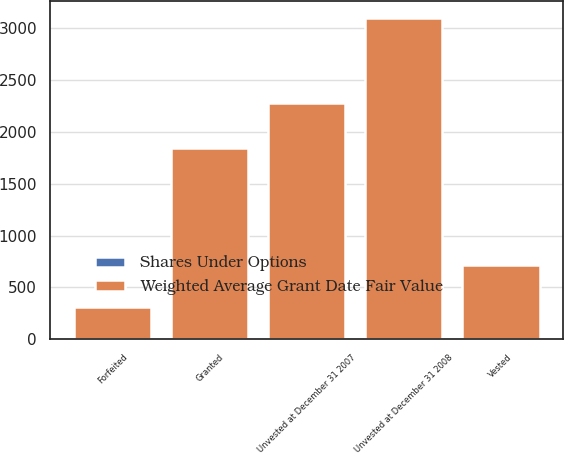<chart> <loc_0><loc_0><loc_500><loc_500><stacked_bar_chart><ecel><fcel>Unvested at December 31 2007<fcel>Granted<fcel>Vested<fcel>Forfeited<fcel>Unvested at December 31 2008<nl><fcel>Weighted Average Grant Date Fair Value<fcel>2277<fcel>1843<fcel>713<fcel>308<fcel>3099<nl><fcel>Shares Under Options<fcel>2.7<fcel>2.91<fcel>2.3<fcel>3.1<fcel>2.95<nl></chart> 